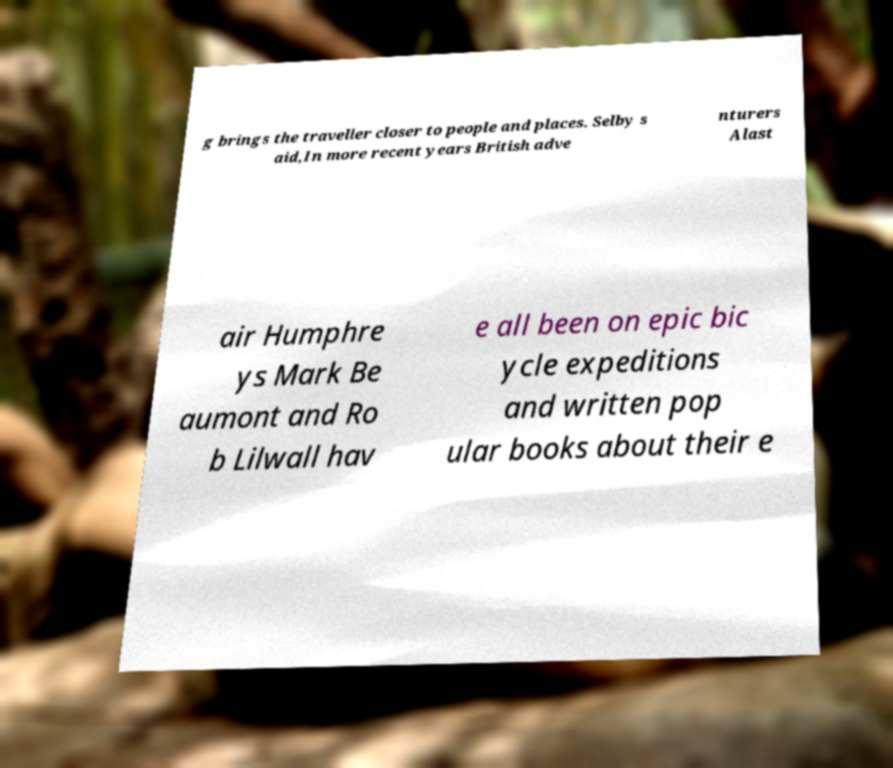I need the written content from this picture converted into text. Can you do that? g brings the traveller closer to people and places. Selby s aid,In more recent years British adve nturers Alast air Humphre ys Mark Be aumont and Ro b Lilwall hav e all been on epic bic ycle expeditions and written pop ular books about their e 